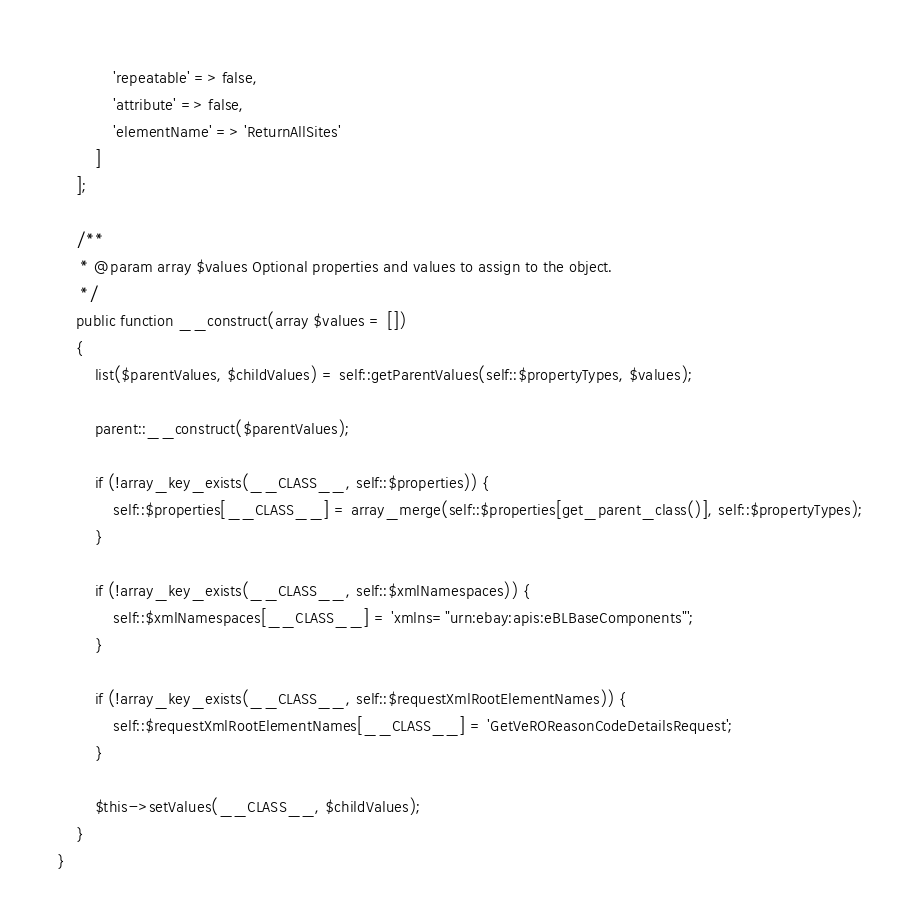<code> <loc_0><loc_0><loc_500><loc_500><_PHP_>            'repeatable' => false,
            'attribute' => false,
            'elementName' => 'ReturnAllSites'
        ]
    ];

    /**
     * @param array $values Optional properties and values to assign to the object.
     */
    public function __construct(array $values = [])
    {
        list($parentValues, $childValues) = self::getParentValues(self::$propertyTypes, $values);

        parent::__construct($parentValues);

        if (!array_key_exists(__CLASS__, self::$properties)) {
            self::$properties[__CLASS__] = array_merge(self::$properties[get_parent_class()], self::$propertyTypes);
        }

        if (!array_key_exists(__CLASS__, self::$xmlNamespaces)) {
            self::$xmlNamespaces[__CLASS__] = 'xmlns="urn:ebay:apis:eBLBaseComponents"';
        }

        if (!array_key_exists(__CLASS__, self::$requestXmlRootElementNames)) {
            self::$requestXmlRootElementNames[__CLASS__] = 'GetVeROReasonCodeDetailsRequest';
        }

        $this->setValues(__CLASS__, $childValues);
    }
}
</code> 